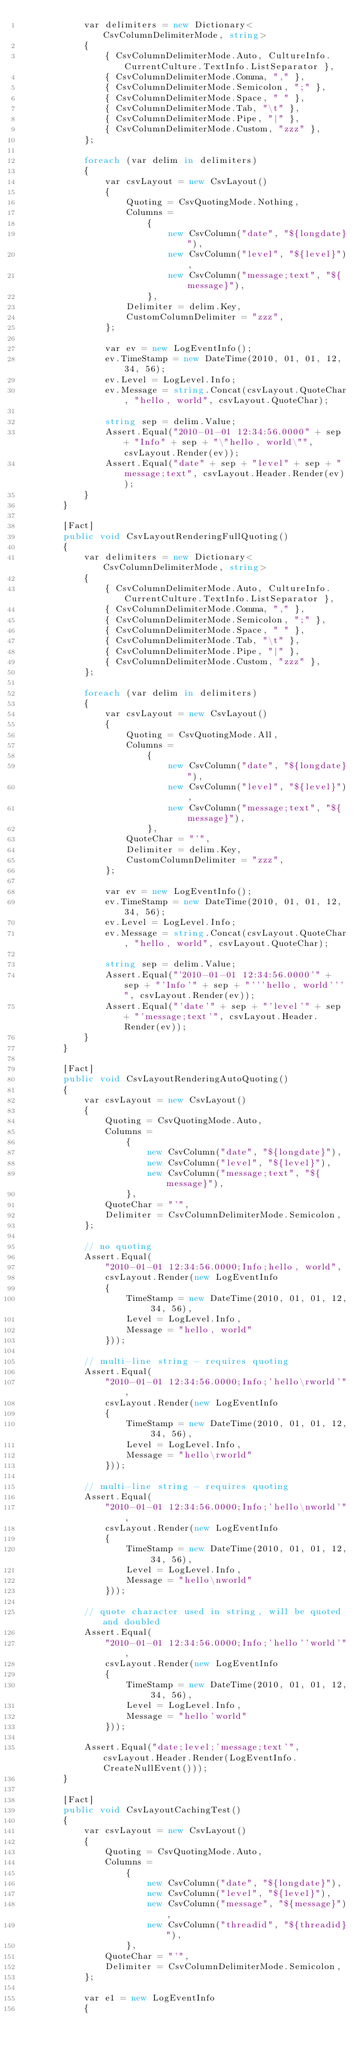Convert code to text. <code><loc_0><loc_0><loc_500><loc_500><_C#_>            var delimiters = new Dictionary<CsvColumnDelimiterMode, string>
            {
                { CsvColumnDelimiterMode.Auto, CultureInfo.CurrentCulture.TextInfo.ListSeparator },
                { CsvColumnDelimiterMode.Comma, "," },
                { CsvColumnDelimiterMode.Semicolon, ";" },
                { CsvColumnDelimiterMode.Space, " " },
                { CsvColumnDelimiterMode.Tab, "\t" },
                { CsvColumnDelimiterMode.Pipe, "|" },
                { CsvColumnDelimiterMode.Custom, "zzz" },
            };

            foreach (var delim in delimiters)
            {
                var csvLayout = new CsvLayout()
                {
                    Quoting = CsvQuotingMode.Nothing,
                    Columns =
                        {
                            new CsvColumn("date", "${longdate}"),
                            new CsvColumn("level", "${level}"),
                            new CsvColumn("message;text", "${message}"),
                        },
                    Delimiter = delim.Key,
                    CustomColumnDelimiter = "zzz",
                };

                var ev = new LogEventInfo();
                ev.TimeStamp = new DateTime(2010, 01, 01, 12, 34, 56);
                ev.Level = LogLevel.Info;
                ev.Message = string.Concat(csvLayout.QuoteChar, "hello, world", csvLayout.QuoteChar);

                string sep = delim.Value;
                Assert.Equal("2010-01-01 12:34:56.0000" + sep + "Info" + sep + "\"hello, world\"", csvLayout.Render(ev));
                Assert.Equal("date" + sep + "level" + sep + "message;text", csvLayout.Header.Render(ev));
            }
        }

        [Fact]
        public void CsvLayoutRenderingFullQuoting()
        {
            var delimiters = new Dictionary<CsvColumnDelimiterMode, string>
            {
                { CsvColumnDelimiterMode.Auto, CultureInfo.CurrentCulture.TextInfo.ListSeparator },
                { CsvColumnDelimiterMode.Comma, "," },
                { CsvColumnDelimiterMode.Semicolon, ";" },
                { CsvColumnDelimiterMode.Space, " " },
                { CsvColumnDelimiterMode.Tab, "\t" },
                { CsvColumnDelimiterMode.Pipe, "|" },
                { CsvColumnDelimiterMode.Custom, "zzz" },
            };

            foreach (var delim in delimiters)
            {
                var csvLayout = new CsvLayout()
                {
                    Quoting = CsvQuotingMode.All,
                    Columns =
                        {
                            new CsvColumn("date", "${longdate}"),
                            new CsvColumn("level", "${level}"),
                            new CsvColumn("message;text", "${message}"),
                        },
                    QuoteChar = "'",
                    Delimiter = delim.Key,
                    CustomColumnDelimiter = "zzz",
                };

                var ev = new LogEventInfo();
                ev.TimeStamp = new DateTime(2010, 01, 01, 12, 34, 56);
                ev.Level = LogLevel.Info;
                ev.Message = string.Concat(csvLayout.QuoteChar, "hello, world", csvLayout.QuoteChar);

                string sep = delim.Value;
                Assert.Equal("'2010-01-01 12:34:56.0000'" + sep + "'Info'" + sep + "'''hello, world'''", csvLayout.Render(ev));
                Assert.Equal("'date'" + sep + "'level'" + sep + "'message;text'", csvLayout.Header.Render(ev));
            }
        }

        [Fact]
        public void CsvLayoutRenderingAutoQuoting()
        {
            var csvLayout = new CsvLayout()
            {
                Quoting = CsvQuotingMode.Auto,
                Columns =
                    {
                        new CsvColumn("date", "${longdate}"),
                        new CsvColumn("level", "${level}"),
                        new CsvColumn("message;text", "${message}"),
                    },
                QuoteChar = "'",
                Delimiter = CsvColumnDelimiterMode.Semicolon,
            };

            // no quoting
            Assert.Equal(
                "2010-01-01 12:34:56.0000;Info;hello, world",
                csvLayout.Render(new LogEventInfo
                {
                    TimeStamp = new DateTime(2010, 01, 01, 12, 34, 56),
                    Level = LogLevel.Info,
                    Message = "hello, world"
                }));

            // multi-line string - requires quoting
            Assert.Equal(
                "2010-01-01 12:34:56.0000;Info;'hello\rworld'",
                csvLayout.Render(new LogEventInfo
                {
                    TimeStamp = new DateTime(2010, 01, 01, 12, 34, 56),
                    Level = LogLevel.Info,
                    Message = "hello\rworld"
                }));

            // multi-line string - requires quoting
            Assert.Equal(
                "2010-01-01 12:34:56.0000;Info;'hello\nworld'",
                csvLayout.Render(new LogEventInfo
                {
                    TimeStamp = new DateTime(2010, 01, 01, 12, 34, 56),
                    Level = LogLevel.Info,
                    Message = "hello\nworld"
                }));

            // quote character used in string, will be quoted and doubled
            Assert.Equal(
                "2010-01-01 12:34:56.0000;Info;'hello''world'",
                csvLayout.Render(new LogEventInfo
                {
                    TimeStamp = new DateTime(2010, 01, 01, 12, 34, 56),
                    Level = LogLevel.Info,
                    Message = "hello'world"
                }));

            Assert.Equal("date;level;'message;text'", csvLayout.Header.Render(LogEventInfo.CreateNullEvent()));
        }

        [Fact]
        public void CsvLayoutCachingTest()
        {
            var csvLayout = new CsvLayout()
            {
                Quoting = CsvQuotingMode.Auto,
                Columns =
                    {
                        new CsvColumn("date", "${longdate}"),
                        new CsvColumn("level", "${level}"),
                        new CsvColumn("message", "${message}"),
                        new CsvColumn("threadid", "${threadid}"),
                    },
                QuoteChar = "'",
                Delimiter = CsvColumnDelimiterMode.Semicolon,
            };

            var e1 = new LogEventInfo
            {</code> 